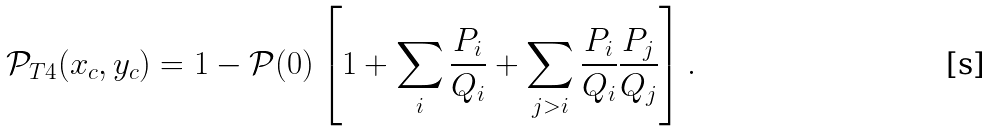Convert formula to latex. <formula><loc_0><loc_0><loc_500><loc_500>\mathcal { P } _ { T 4 } ( x _ { c } , y _ { c } ) = 1 - \mathcal { P } ( 0 ) \left [ 1 + \sum _ { i } \frac { P _ { i } } { Q _ { i } } + \sum _ { j > i } \frac { P _ { i } } { Q _ { i } } \frac { P _ { j } } { Q _ { j } } \right ] .</formula> 